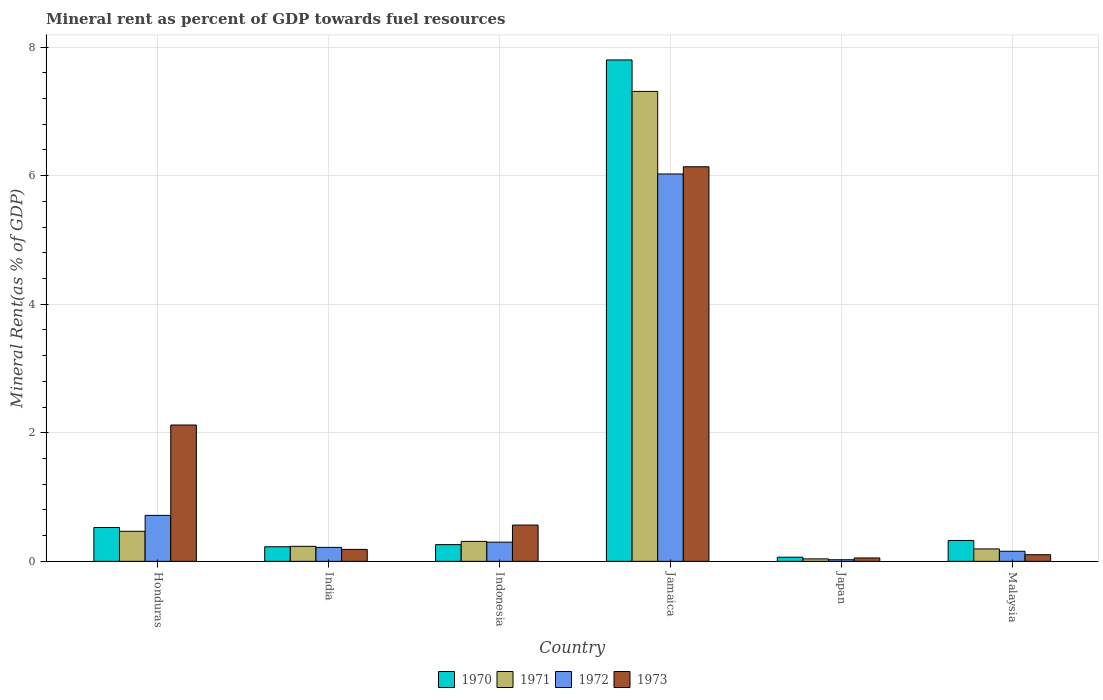How many different coloured bars are there?
Your answer should be compact. 4. How many groups of bars are there?
Your answer should be very brief. 6. Are the number of bars on each tick of the X-axis equal?
Provide a succinct answer. Yes. How many bars are there on the 1st tick from the left?
Give a very brief answer. 4. What is the label of the 6th group of bars from the left?
Give a very brief answer. Malaysia. What is the mineral rent in 1971 in Jamaica?
Your response must be concise. 7.31. Across all countries, what is the maximum mineral rent in 1971?
Keep it short and to the point. 7.31. Across all countries, what is the minimum mineral rent in 1971?
Give a very brief answer. 0.04. In which country was the mineral rent in 1971 maximum?
Your answer should be compact. Jamaica. In which country was the mineral rent in 1971 minimum?
Offer a very short reply. Japan. What is the total mineral rent in 1970 in the graph?
Ensure brevity in your answer.  9.2. What is the difference between the mineral rent in 1973 in Honduras and that in Indonesia?
Ensure brevity in your answer.  1.56. What is the difference between the mineral rent in 1971 in Japan and the mineral rent in 1973 in Honduras?
Offer a very short reply. -2.08. What is the average mineral rent in 1970 per country?
Your response must be concise. 1.53. What is the difference between the mineral rent of/in 1972 and mineral rent of/in 1970 in Indonesia?
Your answer should be compact. 0.04. In how many countries, is the mineral rent in 1973 greater than 2.4 %?
Make the answer very short. 1. What is the ratio of the mineral rent in 1973 in Honduras to that in Jamaica?
Keep it short and to the point. 0.35. Is the mineral rent in 1971 in India less than that in Japan?
Make the answer very short. No. Is the difference between the mineral rent in 1972 in Jamaica and Malaysia greater than the difference between the mineral rent in 1970 in Jamaica and Malaysia?
Your answer should be very brief. No. What is the difference between the highest and the second highest mineral rent in 1972?
Provide a succinct answer. 0.42. What is the difference between the highest and the lowest mineral rent in 1972?
Keep it short and to the point. 6. In how many countries, is the mineral rent in 1973 greater than the average mineral rent in 1973 taken over all countries?
Offer a very short reply. 2. Is it the case that in every country, the sum of the mineral rent in 1973 and mineral rent in 1970 is greater than the sum of mineral rent in 1971 and mineral rent in 1972?
Offer a terse response. No. Are all the bars in the graph horizontal?
Your response must be concise. No. How many countries are there in the graph?
Keep it short and to the point. 6. What is the difference between two consecutive major ticks on the Y-axis?
Your answer should be very brief. 2. Does the graph contain any zero values?
Offer a terse response. No. How many legend labels are there?
Make the answer very short. 4. What is the title of the graph?
Your response must be concise. Mineral rent as percent of GDP towards fuel resources. Does "1974" appear as one of the legend labels in the graph?
Make the answer very short. No. What is the label or title of the X-axis?
Ensure brevity in your answer.  Country. What is the label or title of the Y-axis?
Provide a short and direct response. Mineral Rent(as % of GDP). What is the Mineral Rent(as % of GDP) of 1970 in Honduras?
Offer a very short reply. 0.53. What is the Mineral Rent(as % of GDP) of 1971 in Honduras?
Offer a very short reply. 0.47. What is the Mineral Rent(as % of GDP) in 1972 in Honduras?
Keep it short and to the point. 0.72. What is the Mineral Rent(as % of GDP) of 1973 in Honduras?
Offer a very short reply. 2.12. What is the Mineral Rent(as % of GDP) in 1970 in India?
Ensure brevity in your answer.  0.23. What is the Mineral Rent(as % of GDP) in 1971 in India?
Your response must be concise. 0.23. What is the Mineral Rent(as % of GDP) in 1972 in India?
Provide a succinct answer. 0.22. What is the Mineral Rent(as % of GDP) of 1973 in India?
Your answer should be compact. 0.19. What is the Mineral Rent(as % of GDP) of 1970 in Indonesia?
Offer a terse response. 0.26. What is the Mineral Rent(as % of GDP) of 1971 in Indonesia?
Offer a very short reply. 0.31. What is the Mineral Rent(as % of GDP) of 1972 in Indonesia?
Give a very brief answer. 0.3. What is the Mineral Rent(as % of GDP) of 1973 in Indonesia?
Provide a short and direct response. 0.56. What is the Mineral Rent(as % of GDP) in 1970 in Jamaica?
Ensure brevity in your answer.  7.8. What is the Mineral Rent(as % of GDP) of 1971 in Jamaica?
Your answer should be compact. 7.31. What is the Mineral Rent(as % of GDP) of 1972 in Jamaica?
Provide a short and direct response. 6.03. What is the Mineral Rent(as % of GDP) in 1973 in Jamaica?
Offer a very short reply. 6.14. What is the Mineral Rent(as % of GDP) of 1970 in Japan?
Your answer should be compact. 0.06. What is the Mineral Rent(as % of GDP) in 1971 in Japan?
Give a very brief answer. 0.04. What is the Mineral Rent(as % of GDP) of 1972 in Japan?
Give a very brief answer. 0.03. What is the Mineral Rent(as % of GDP) of 1973 in Japan?
Keep it short and to the point. 0.05. What is the Mineral Rent(as % of GDP) in 1970 in Malaysia?
Your response must be concise. 0.33. What is the Mineral Rent(as % of GDP) in 1971 in Malaysia?
Provide a short and direct response. 0.19. What is the Mineral Rent(as % of GDP) of 1972 in Malaysia?
Make the answer very short. 0.16. What is the Mineral Rent(as % of GDP) of 1973 in Malaysia?
Give a very brief answer. 0.1. Across all countries, what is the maximum Mineral Rent(as % of GDP) of 1970?
Offer a terse response. 7.8. Across all countries, what is the maximum Mineral Rent(as % of GDP) in 1971?
Provide a succinct answer. 7.31. Across all countries, what is the maximum Mineral Rent(as % of GDP) of 1972?
Give a very brief answer. 6.03. Across all countries, what is the maximum Mineral Rent(as % of GDP) of 1973?
Provide a succinct answer. 6.14. Across all countries, what is the minimum Mineral Rent(as % of GDP) in 1970?
Provide a short and direct response. 0.06. Across all countries, what is the minimum Mineral Rent(as % of GDP) in 1971?
Your answer should be very brief. 0.04. Across all countries, what is the minimum Mineral Rent(as % of GDP) in 1972?
Provide a succinct answer. 0.03. Across all countries, what is the minimum Mineral Rent(as % of GDP) in 1973?
Your response must be concise. 0.05. What is the total Mineral Rent(as % of GDP) of 1970 in the graph?
Your response must be concise. 9.2. What is the total Mineral Rent(as % of GDP) of 1971 in the graph?
Make the answer very short. 8.55. What is the total Mineral Rent(as % of GDP) in 1972 in the graph?
Offer a very short reply. 7.44. What is the total Mineral Rent(as % of GDP) in 1973 in the graph?
Offer a very short reply. 9.17. What is the difference between the Mineral Rent(as % of GDP) of 1970 in Honduras and that in India?
Make the answer very short. 0.3. What is the difference between the Mineral Rent(as % of GDP) in 1971 in Honduras and that in India?
Keep it short and to the point. 0.23. What is the difference between the Mineral Rent(as % of GDP) of 1972 in Honduras and that in India?
Ensure brevity in your answer.  0.5. What is the difference between the Mineral Rent(as % of GDP) of 1973 in Honduras and that in India?
Ensure brevity in your answer.  1.94. What is the difference between the Mineral Rent(as % of GDP) of 1970 in Honduras and that in Indonesia?
Your answer should be compact. 0.27. What is the difference between the Mineral Rent(as % of GDP) of 1971 in Honduras and that in Indonesia?
Your response must be concise. 0.16. What is the difference between the Mineral Rent(as % of GDP) of 1972 in Honduras and that in Indonesia?
Provide a succinct answer. 0.42. What is the difference between the Mineral Rent(as % of GDP) in 1973 in Honduras and that in Indonesia?
Offer a terse response. 1.56. What is the difference between the Mineral Rent(as % of GDP) in 1970 in Honduras and that in Jamaica?
Ensure brevity in your answer.  -7.27. What is the difference between the Mineral Rent(as % of GDP) of 1971 in Honduras and that in Jamaica?
Keep it short and to the point. -6.84. What is the difference between the Mineral Rent(as % of GDP) of 1972 in Honduras and that in Jamaica?
Your answer should be compact. -5.31. What is the difference between the Mineral Rent(as % of GDP) in 1973 in Honduras and that in Jamaica?
Ensure brevity in your answer.  -4.02. What is the difference between the Mineral Rent(as % of GDP) in 1970 in Honduras and that in Japan?
Offer a terse response. 0.46. What is the difference between the Mineral Rent(as % of GDP) in 1971 in Honduras and that in Japan?
Offer a very short reply. 0.43. What is the difference between the Mineral Rent(as % of GDP) of 1972 in Honduras and that in Japan?
Offer a terse response. 0.69. What is the difference between the Mineral Rent(as % of GDP) of 1973 in Honduras and that in Japan?
Give a very brief answer. 2.07. What is the difference between the Mineral Rent(as % of GDP) of 1970 in Honduras and that in Malaysia?
Offer a very short reply. 0.2. What is the difference between the Mineral Rent(as % of GDP) in 1971 in Honduras and that in Malaysia?
Give a very brief answer. 0.27. What is the difference between the Mineral Rent(as % of GDP) in 1972 in Honduras and that in Malaysia?
Give a very brief answer. 0.56. What is the difference between the Mineral Rent(as % of GDP) of 1973 in Honduras and that in Malaysia?
Make the answer very short. 2.02. What is the difference between the Mineral Rent(as % of GDP) of 1970 in India and that in Indonesia?
Your response must be concise. -0.03. What is the difference between the Mineral Rent(as % of GDP) of 1971 in India and that in Indonesia?
Offer a very short reply. -0.08. What is the difference between the Mineral Rent(as % of GDP) in 1972 in India and that in Indonesia?
Your answer should be very brief. -0.08. What is the difference between the Mineral Rent(as % of GDP) in 1973 in India and that in Indonesia?
Offer a terse response. -0.38. What is the difference between the Mineral Rent(as % of GDP) in 1970 in India and that in Jamaica?
Offer a very short reply. -7.57. What is the difference between the Mineral Rent(as % of GDP) in 1971 in India and that in Jamaica?
Offer a terse response. -7.08. What is the difference between the Mineral Rent(as % of GDP) in 1972 in India and that in Jamaica?
Your answer should be very brief. -5.81. What is the difference between the Mineral Rent(as % of GDP) of 1973 in India and that in Jamaica?
Provide a succinct answer. -5.95. What is the difference between the Mineral Rent(as % of GDP) of 1970 in India and that in Japan?
Ensure brevity in your answer.  0.16. What is the difference between the Mineral Rent(as % of GDP) of 1971 in India and that in Japan?
Make the answer very short. 0.2. What is the difference between the Mineral Rent(as % of GDP) in 1972 in India and that in Japan?
Make the answer very short. 0.19. What is the difference between the Mineral Rent(as % of GDP) of 1973 in India and that in Japan?
Ensure brevity in your answer.  0.13. What is the difference between the Mineral Rent(as % of GDP) of 1970 in India and that in Malaysia?
Your answer should be very brief. -0.1. What is the difference between the Mineral Rent(as % of GDP) of 1971 in India and that in Malaysia?
Ensure brevity in your answer.  0.04. What is the difference between the Mineral Rent(as % of GDP) in 1972 in India and that in Malaysia?
Keep it short and to the point. 0.06. What is the difference between the Mineral Rent(as % of GDP) of 1973 in India and that in Malaysia?
Offer a terse response. 0.08. What is the difference between the Mineral Rent(as % of GDP) in 1970 in Indonesia and that in Jamaica?
Provide a succinct answer. -7.54. What is the difference between the Mineral Rent(as % of GDP) in 1971 in Indonesia and that in Jamaica?
Give a very brief answer. -7. What is the difference between the Mineral Rent(as % of GDP) in 1972 in Indonesia and that in Jamaica?
Your response must be concise. -5.73. What is the difference between the Mineral Rent(as % of GDP) of 1973 in Indonesia and that in Jamaica?
Your answer should be very brief. -5.57. What is the difference between the Mineral Rent(as % of GDP) in 1970 in Indonesia and that in Japan?
Provide a succinct answer. 0.2. What is the difference between the Mineral Rent(as % of GDP) of 1971 in Indonesia and that in Japan?
Offer a terse response. 0.27. What is the difference between the Mineral Rent(as % of GDP) of 1972 in Indonesia and that in Japan?
Ensure brevity in your answer.  0.27. What is the difference between the Mineral Rent(as % of GDP) of 1973 in Indonesia and that in Japan?
Keep it short and to the point. 0.51. What is the difference between the Mineral Rent(as % of GDP) of 1970 in Indonesia and that in Malaysia?
Your answer should be very brief. -0.07. What is the difference between the Mineral Rent(as % of GDP) of 1971 in Indonesia and that in Malaysia?
Offer a terse response. 0.12. What is the difference between the Mineral Rent(as % of GDP) in 1972 in Indonesia and that in Malaysia?
Provide a short and direct response. 0.14. What is the difference between the Mineral Rent(as % of GDP) in 1973 in Indonesia and that in Malaysia?
Keep it short and to the point. 0.46. What is the difference between the Mineral Rent(as % of GDP) of 1970 in Jamaica and that in Japan?
Keep it short and to the point. 7.73. What is the difference between the Mineral Rent(as % of GDP) in 1971 in Jamaica and that in Japan?
Ensure brevity in your answer.  7.27. What is the difference between the Mineral Rent(as % of GDP) of 1972 in Jamaica and that in Japan?
Your answer should be compact. 6. What is the difference between the Mineral Rent(as % of GDP) in 1973 in Jamaica and that in Japan?
Make the answer very short. 6.08. What is the difference between the Mineral Rent(as % of GDP) in 1970 in Jamaica and that in Malaysia?
Your answer should be very brief. 7.47. What is the difference between the Mineral Rent(as % of GDP) of 1971 in Jamaica and that in Malaysia?
Provide a short and direct response. 7.12. What is the difference between the Mineral Rent(as % of GDP) of 1972 in Jamaica and that in Malaysia?
Your answer should be compact. 5.87. What is the difference between the Mineral Rent(as % of GDP) of 1973 in Jamaica and that in Malaysia?
Your response must be concise. 6.03. What is the difference between the Mineral Rent(as % of GDP) of 1970 in Japan and that in Malaysia?
Offer a very short reply. -0.26. What is the difference between the Mineral Rent(as % of GDP) of 1971 in Japan and that in Malaysia?
Offer a very short reply. -0.16. What is the difference between the Mineral Rent(as % of GDP) of 1972 in Japan and that in Malaysia?
Provide a succinct answer. -0.13. What is the difference between the Mineral Rent(as % of GDP) in 1973 in Japan and that in Malaysia?
Your response must be concise. -0.05. What is the difference between the Mineral Rent(as % of GDP) of 1970 in Honduras and the Mineral Rent(as % of GDP) of 1971 in India?
Keep it short and to the point. 0.29. What is the difference between the Mineral Rent(as % of GDP) in 1970 in Honduras and the Mineral Rent(as % of GDP) in 1972 in India?
Give a very brief answer. 0.31. What is the difference between the Mineral Rent(as % of GDP) in 1970 in Honduras and the Mineral Rent(as % of GDP) in 1973 in India?
Provide a succinct answer. 0.34. What is the difference between the Mineral Rent(as % of GDP) in 1971 in Honduras and the Mineral Rent(as % of GDP) in 1972 in India?
Provide a succinct answer. 0.25. What is the difference between the Mineral Rent(as % of GDP) of 1971 in Honduras and the Mineral Rent(as % of GDP) of 1973 in India?
Provide a succinct answer. 0.28. What is the difference between the Mineral Rent(as % of GDP) of 1972 in Honduras and the Mineral Rent(as % of GDP) of 1973 in India?
Ensure brevity in your answer.  0.53. What is the difference between the Mineral Rent(as % of GDP) of 1970 in Honduras and the Mineral Rent(as % of GDP) of 1971 in Indonesia?
Provide a short and direct response. 0.22. What is the difference between the Mineral Rent(as % of GDP) of 1970 in Honduras and the Mineral Rent(as % of GDP) of 1972 in Indonesia?
Your response must be concise. 0.23. What is the difference between the Mineral Rent(as % of GDP) in 1970 in Honduras and the Mineral Rent(as % of GDP) in 1973 in Indonesia?
Give a very brief answer. -0.04. What is the difference between the Mineral Rent(as % of GDP) of 1971 in Honduras and the Mineral Rent(as % of GDP) of 1972 in Indonesia?
Provide a short and direct response. 0.17. What is the difference between the Mineral Rent(as % of GDP) of 1971 in Honduras and the Mineral Rent(as % of GDP) of 1973 in Indonesia?
Your answer should be compact. -0.1. What is the difference between the Mineral Rent(as % of GDP) of 1972 in Honduras and the Mineral Rent(as % of GDP) of 1973 in Indonesia?
Keep it short and to the point. 0.15. What is the difference between the Mineral Rent(as % of GDP) in 1970 in Honduras and the Mineral Rent(as % of GDP) in 1971 in Jamaica?
Provide a succinct answer. -6.78. What is the difference between the Mineral Rent(as % of GDP) of 1970 in Honduras and the Mineral Rent(as % of GDP) of 1972 in Jamaica?
Give a very brief answer. -5.5. What is the difference between the Mineral Rent(as % of GDP) in 1970 in Honduras and the Mineral Rent(as % of GDP) in 1973 in Jamaica?
Provide a short and direct response. -5.61. What is the difference between the Mineral Rent(as % of GDP) of 1971 in Honduras and the Mineral Rent(as % of GDP) of 1972 in Jamaica?
Make the answer very short. -5.56. What is the difference between the Mineral Rent(as % of GDP) of 1971 in Honduras and the Mineral Rent(as % of GDP) of 1973 in Jamaica?
Offer a terse response. -5.67. What is the difference between the Mineral Rent(as % of GDP) of 1972 in Honduras and the Mineral Rent(as % of GDP) of 1973 in Jamaica?
Your answer should be very brief. -5.42. What is the difference between the Mineral Rent(as % of GDP) of 1970 in Honduras and the Mineral Rent(as % of GDP) of 1971 in Japan?
Your answer should be compact. 0.49. What is the difference between the Mineral Rent(as % of GDP) in 1970 in Honduras and the Mineral Rent(as % of GDP) in 1972 in Japan?
Give a very brief answer. 0.5. What is the difference between the Mineral Rent(as % of GDP) of 1970 in Honduras and the Mineral Rent(as % of GDP) of 1973 in Japan?
Your answer should be compact. 0.47. What is the difference between the Mineral Rent(as % of GDP) of 1971 in Honduras and the Mineral Rent(as % of GDP) of 1972 in Japan?
Offer a very short reply. 0.44. What is the difference between the Mineral Rent(as % of GDP) of 1971 in Honduras and the Mineral Rent(as % of GDP) of 1973 in Japan?
Your response must be concise. 0.41. What is the difference between the Mineral Rent(as % of GDP) of 1972 in Honduras and the Mineral Rent(as % of GDP) of 1973 in Japan?
Offer a very short reply. 0.66. What is the difference between the Mineral Rent(as % of GDP) in 1970 in Honduras and the Mineral Rent(as % of GDP) in 1971 in Malaysia?
Offer a terse response. 0.33. What is the difference between the Mineral Rent(as % of GDP) of 1970 in Honduras and the Mineral Rent(as % of GDP) of 1972 in Malaysia?
Offer a very short reply. 0.37. What is the difference between the Mineral Rent(as % of GDP) of 1970 in Honduras and the Mineral Rent(as % of GDP) of 1973 in Malaysia?
Give a very brief answer. 0.42. What is the difference between the Mineral Rent(as % of GDP) of 1971 in Honduras and the Mineral Rent(as % of GDP) of 1972 in Malaysia?
Offer a very short reply. 0.31. What is the difference between the Mineral Rent(as % of GDP) in 1971 in Honduras and the Mineral Rent(as % of GDP) in 1973 in Malaysia?
Your response must be concise. 0.36. What is the difference between the Mineral Rent(as % of GDP) in 1972 in Honduras and the Mineral Rent(as % of GDP) in 1973 in Malaysia?
Offer a very short reply. 0.61. What is the difference between the Mineral Rent(as % of GDP) of 1970 in India and the Mineral Rent(as % of GDP) of 1971 in Indonesia?
Ensure brevity in your answer.  -0.08. What is the difference between the Mineral Rent(as % of GDP) in 1970 in India and the Mineral Rent(as % of GDP) in 1972 in Indonesia?
Your answer should be compact. -0.07. What is the difference between the Mineral Rent(as % of GDP) of 1970 in India and the Mineral Rent(as % of GDP) of 1973 in Indonesia?
Your response must be concise. -0.34. What is the difference between the Mineral Rent(as % of GDP) of 1971 in India and the Mineral Rent(as % of GDP) of 1972 in Indonesia?
Keep it short and to the point. -0.07. What is the difference between the Mineral Rent(as % of GDP) of 1971 in India and the Mineral Rent(as % of GDP) of 1973 in Indonesia?
Provide a succinct answer. -0.33. What is the difference between the Mineral Rent(as % of GDP) of 1972 in India and the Mineral Rent(as % of GDP) of 1973 in Indonesia?
Give a very brief answer. -0.35. What is the difference between the Mineral Rent(as % of GDP) in 1970 in India and the Mineral Rent(as % of GDP) in 1971 in Jamaica?
Provide a succinct answer. -7.08. What is the difference between the Mineral Rent(as % of GDP) of 1970 in India and the Mineral Rent(as % of GDP) of 1972 in Jamaica?
Make the answer very short. -5.8. What is the difference between the Mineral Rent(as % of GDP) in 1970 in India and the Mineral Rent(as % of GDP) in 1973 in Jamaica?
Provide a succinct answer. -5.91. What is the difference between the Mineral Rent(as % of GDP) in 1971 in India and the Mineral Rent(as % of GDP) in 1972 in Jamaica?
Keep it short and to the point. -5.79. What is the difference between the Mineral Rent(as % of GDP) of 1971 in India and the Mineral Rent(as % of GDP) of 1973 in Jamaica?
Your answer should be very brief. -5.9. What is the difference between the Mineral Rent(as % of GDP) in 1972 in India and the Mineral Rent(as % of GDP) in 1973 in Jamaica?
Provide a short and direct response. -5.92. What is the difference between the Mineral Rent(as % of GDP) of 1970 in India and the Mineral Rent(as % of GDP) of 1971 in Japan?
Your answer should be very brief. 0.19. What is the difference between the Mineral Rent(as % of GDP) in 1970 in India and the Mineral Rent(as % of GDP) in 1972 in Japan?
Give a very brief answer. 0.2. What is the difference between the Mineral Rent(as % of GDP) of 1970 in India and the Mineral Rent(as % of GDP) of 1973 in Japan?
Keep it short and to the point. 0.17. What is the difference between the Mineral Rent(as % of GDP) of 1971 in India and the Mineral Rent(as % of GDP) of 1972 in Japan?
Make the answer very short. 0.21. What is the difference between the Mineral Rent(as % of GDP) of 1971 in India and the Mineral Rent(as % of GDP) of 1973 in Japan?
Your response must be concise. 0.18. What is the difference between the Mineral Rent(as % of GDP) of 1972 in India and the Mineral Rent(as % of GDP) of 1973 in Japan?
Offer a very short reply. 0.16. What is the difference between the Mineral Rent(as % of GDP) in 1970 in India and the Mineral Rent(as % of GDP) in 1972 in Malaysia?
Offer a terse response. 0.07. What is the difference between the Mineral Rent(as % of GDP) in 1970 in India and the Mineral Rent(as % of GDP) in 1973 in Malaysia?
Keep it short and to the point. 0.12. What is the difference between the Mineral Rent(as % of GDP) of 1971 in India and the Mineral Rent(as % of GDP) of 1972 in Malaysia?
Your answer should be compact. 0.08. What is the difference between the Mineral Rent(as % of GDP) in 1971 in India and the Mineral Rent(as % of GDP) in 1973 in Malaysia?
Give a very brief answer. 0.13. What is the difference between the Mineral Rent(as % of GDP) in 1972 in India and the Mineral Rent(as % of GDP) in 1973 in Malaysia?
Provide a short and direct response. 0.11. What is the difference between the Mineral Rent(as % of GDP) in 1970 in Indonesia and the Mineral Rent(as % of GDP) in 1971 in Jamaica?
Make the answer very short. -7.05. What is the difference between the Mineral Rent(as % of GDP) of 1970 in Indonesia and the Mineral Rent(as % of GDP) of 1972 in Jamaica?
Your answer should be compact. -5.77. What is the difference between the Mineral Rent(as % of GDP) of 1970 in Indonesia and the Mineral Rent(as % of GDP) of 1973 in Jamaica?
Your response must be concise. -5.88. What is the difference between the Mineral Rent(as % of GDP) in 1971 in Indonesia and the Mineral Rent(as % of GDP) in 1972 in Jamaica?
Ensure brevity in your answer.  -5.72. What is the difference between the Mineral Rent(as % of GDP) of 1971 in Indonesia and the Mineral Rent(as % of GDP) of 1973 in Jamaica?
Give a very brief answer. -5.83. What is the difference between the Mineral Rent(as % of GDP) of 1972 in Indonesia and the Mineral Rent(as % of GDP) of 1973 in Jamaica?
Your response must be concise. -5.84. What is the difference between the Mineral Rent(as % of GDP) in 1970 in Indonesia and the Mineral Rent(as % of GDP) in 1971 in Japan?
Your answer should be compact. 0.22. What is the difference between the Mineral Rent(as % of GDP) in 1970 in Indonesia and the Mineral Rent(as % of GDP) in 1972 in Japan?
Keep it short and to the point. 0.23. What is the difference between the Mineral Rent(as % of GDP) in 1970 in Indonesia and the Mineral Rent(as % of GDP) in 1973 in Japan?
Offer a very short reply. 0.21. What is the difference between the Mineral Rent(as % of GDP) in 1971 in Indonesia and the Mineral Rent(as % of GDP) in 1972 in Japan?
Keep it short and to the point. 0.29. What is the difference between the Mineral Rent(as % of GDP) of 1971 in Indonesia and the Mineral Rent(as % of GDP) of 1973 in Japan?
Provide a short and direct response. 0.26. What is the difference between the Mineral Rent(as % of GDP) of 1972 in Indonesia and the Mineral Rent(as % of GDP) of 1973 in Japan?
Provide a succinct answer. 0.25. What is the difference between the Mineral Rent(as % of GDP) of 1970 in Indonesia and the Mineral Rent(as % of GDP) of 1971 in Malaysia?
Provide a succinct answer. 0.07. What is the difference between the Mineral Rent(as % of GDP) in 1970 in Indonesia and the Mineral Rent(as % of GDP) in 1972 in Malaysia?
Your answer should be compact. 0.1. What is the difference between the Mineral Rent(as % of GDP) of 1970 in Indonesia and the Mineral Rent(as % of GDP) of 1973 in Malaysia?
Offer a terse response. 0.16. What is the difference between the Mineral Rent(as % of GDP) of 1971 in Indonesia and the Mineral Rent(as % of GDP) of 1972 in Malaysia?
Provide a short and direct response. 0.15. What is the difference between the Mineral Rent(as % of GDP) of 1971 in Indonesia and the Mineral Rent(as % of GDP) of 1973 in Malaysia?
Offer a terse response. 0.21. What is the difference between the Mineral Rent(as % of GDP) of 1972 in Indonesia and the Mineral Rent(as % of GDP) of 1973 in Malaysia?
Your answer should be compact. 0.2. What is the difference between the Mineral Rent(as % of GDP) of 1970 in Jamaica and the Mineral Rent(as % of GDP) of 1971 in Japan?
Provide a short and direct response. 7.76. What is the difference between the Mineral Rent(as % of GDP) of 1970 in Jamaica and the Mineral Rent(as % of GDP) of 1972 in Japan?
Offer a very short reply. 7.77. What is the difference between the Mineral Rent(as % of GDP) in 1970 in Jamaica and the Mineral Rent(as % of GDP) in 1973 in Japan?
Your response must be concise. 7.75. What is the difference between the Mineral Rent(as % of GDP) of 1971 in Jamaica and the Mineral Rent(as % of GDP) of 1972 in Japan?
Your answer should be compact. 7.28. What is the difference between the Mineral Rent(as % of GDP) of 1971 in Jamaica and the Mineral Rent(as % of GDP) of 1973 in Japan?
Provide a succinct answer. 7.26. What is the difference between the Mineral Rent(as % of GDP) of 1972 in Jamaica and the Mineral Rent(as % of GDP) of 1973 in Japan?
Your answer should be very brief. 5.97. What is the difference between the Mineral Rent(as % of GDP) in 1970 in Jamaica and the Mineral Rent(as % of GDP) in 1971 in Malaysia?
Provide a short and direct response. 7.61. What is the difference between the Mineral Rent(as % of GDP) in 1970 in Jamaica and the Mineral Rent(as % of GDP) in 1972 in Malaysia?
Offer a very short reply. 7.64. What is the difference between the Mineral Rent(as % of GDP) in 1970 in Jamaica and the Mineral Rent(as % of GDP) in 1973 in Malaysia?
Offer a terse response. 7.7. What is the difference between the Mineral Rent(as % of GDP) of 1971 in Jamaica and the Mineral Rent(as % of GDP) of 1972 in Malaysia?
Your response must be concise. 7.15. What is the difference between the Mineral Rent(as % of GDP) in 1971 in Jamaica and the Mineral Rent(as % of GDP) in 1973 in Malaysia?
Provide a short and direct response. 7.21. What is the difference between the Mineral Rent(as % of GDP) of 1972 in Jamaica and the Mineral Rent(as % of GDP) of 1973 in Malaysia?
Offer a very short reply. 5.92. What is the difference between the Mineral Rent(as % of GDP) of 1970 in Japan and the Mineral Rent(as % of GDP) of 1971 in Malaysia?
Provide a short and direct response. -0.13. What is the difference between the Mineral Rent(as % of GDP) of 1970 in Japan and the Mineral Rent(as % of GDP) of 1972 in Malaysia?
Provide a succinct answer. -0.09. What is the difference between the Mineral Rent(as % of GDP) in 1970 in Japan and the Mineral Rent(as % of GDP) in 1973 in Malaysia?
Offer a very short reply. -0.04. What is the difference between the Mineral Rent(as % of GDP) of 1971 in Japan and the Mineral Rent(as % of GDP) of 1972 in Malaysia?
Keep it short and to the point. -0.12. What is the difference between the Mineral Rent(as % of GDP) of 1971 in Japan and the Mineral Rent(as % of GDP) of 1973 in Malaysia?
Offer a very short reply. -0.06. What is the difference between the Mineral Rent(as % of GDP) of 1972 in Japan and the Mineral Rent(as % of GDP) of 1973 in Malaysia?
Keep it short and to the point. -0.08. What is the average Mineral Rent(as % of GDP) of 1970 per country?
Offer a terse response. 1.53. What is the average Mineral Rent(as % of GDP) of 1971 per country?
Give a very brief answer. 1.43. What is the average Mineral Rent(as % of GDP) in 1972 per country?
Your answer should be very brief. 1.24. What is the average Mineral Rent(as % of GDP) of 1973 per country?
Provide a short and direct response. 1.53. What is the difference between the Mineral Rent(as % of GDP) of 1970 and Mineral Rent(as % of GDP) of 1971 in Honduras?
Provide a succinct answer. 0.06. What is the difference between the Mineral Rent(as % of GDP) of 1970 and Mineral Rent(as % of GDP) of 1972 in Honduras?
Your answer should be compact. -0.19. What is the difference between the Mineral Rent(as % of GDP) in 1970 and Mineral Rent(as % of GDP) in 1973 in Honduras?
Your answer should be compact. -1.59. What is the difference between the Mineral Rent(as % of GDP) in 1971 and Mineral Rent(as % of GDP) in 1972 in Honduras?
Keep it short and to the point. -0.25. What is the difference between the Mineral Rent(as % of GDP) of 1971 and Mineral Rent(as % of GDP) of 1973 in Honduras?
Provide a short and direct response. -1.65. What is the difference between the Mineral Rent(as % of GDP) in 1972 and Mineral Rent(as % of GDP) in 1973 in Honduras?
Your answer should be compact. -1.41. What is the difference between the Mineral Rent(as % of GDP) of 1970 and Mineral Rent(as % of GDP) of 1971 in India?
Give a very brief answer. -0.01. What is the difference between the Mineral Rent(as % of GDP) of 1970 and Mineral Rent(as % of GDP) of 1972 in India?
Provide a short and direct response. 0.01. What is the difference between the Mineral Rent(as % of GDP) in 1970 and Mineral Rent(as % of GDP) in 1973 in India?
Your answer should be compact. 0.04. What is the difference between the Mineral Rent(as % of GDP) of 1971 and Mineral Rent(as % of GDP) of 1972 in India?
Give a very brief answer. 0.02. What is the difference between the Mineral Rent(as % of GDP) in 1971 and Mineral Rent(as % of GDP) in 1973 in India?
Provide a short and direct response. 0.05. What is the difference between the Mineral Rent(as % of GDP) of 1972 and Mineral Rent(as % of GDP) of 1973 in India?
Offer a very short reply. 0.03. What is the difference between the Mineral Rent(as % of GDP) of 1970 and Mineral Rent(as % of GDP) of 1971 in Indonesia?
Offer a very short reply. -0.05. What is the difference between the Mineral Rent(as % of GDP) of 1970 and Mineral Rent(as % of GDP) of 1972 in Indonesia?
Offer a terse response. -0.04. What is the difference between the Mineral Rent(as % of GDP) of 1970 and Mineral Rent(as % of GDP) of 1973 in Indonesia?
Your answer should be very brief. -0.3. What is the difference between the Mineral Rent(as % of GDP) in 1971 and Mineral Rent(as % of GDP) in 1972 in Indonesia?
Make the answer very short. 0.01. What is the difference between the Mineral Rent(as % of GDP) of 1971 and Mineral Rent(as % of GDP) of 1973 in Indonesia?
Give a very brief answer. -0.25. What is the difference between the Mineral Rent(as % of GDP) in 1972 and Mineral Rent(as % of GDP) in 1973 in Indonesia?
Offer a terse response. -0.27. What is the difference between the Mineral Rent(as % of GDP) of 1970 and Mineral Rent(as % of GDP) of 1971 in Jamaica?
Offer a terse response. 0.49. What is the difference between the Mineral Rent(as % of GDP) of 1970 and Mineral Rent(as % of GDP) of 1972 in Jamaica?
Offer a very short reply. 1.77. What is the difference between the Mineral Rent(as % of GDP) in 1970 and Mineral Rent(as % of GDP) in 1973 in Jamaica?
Offer a terse response. 1.66. What is the difference between the Mineral Rent(as % of GDP) of 1971 and Mineral Rent(as % of GDP) of 1972 in Jamaica?
Make the answer very short. 1.28. What is the difference between the Mineral Rent(as % of GDP) of 1971 and Mineral Rent(as % of GDP) of 1973 in Jamaica?
Make the answer very short. 1.17. What is the difference between the Mineral Rent(as % of GDP) of 1972 and Mineral Rent(as % of GDP) of 1973 in Jamaica?
Keep it short and to the point. -0.11. What is the difference between the Mineral Rent(as % of GDP) in 1970 and Mineral Rent(as % of GDP) in 1971 in Japan?
Keep it short and to the point. 0.03. What is the difference between the Mineral Rent(as % of GDP) of 1970 and Mineral Rent(as % of GDP) of 1972 in Japan?
Make the answer very short. 0.04. What is the difference between the Mineral Rent(as % of GDP) of 1970 and Mineral Rent(as % of GDP) of 1973 in Japan?
Your answer should be very brief. 0.01. What is the difference between the Mineral Rent(as % of GDP) in 1971 and Mineral Rent(as % of GDP) in 1972 in Japan?
Your answer should be compact. 0.01. What is the difference between the Mineral Rent(as % of GDP) of 1971 and Mineral Rent(as % of GDP) of 1973 in Japan?
Your answer should be very brief. -0.01. What is the difference between the Mineral Rent(as % of GDP) of 1972 and Mineral Rent(as % of GDP) of 1973 in Japan?
Your answer should be very brief. -0.03. What is the difference between the Mineral Rent(as % of GDP) in 1970 and Mineral Rent(as % of GDP) in 1971 in Malaysia?
Provide a short and direct response. 0.13. What is the difference between the Mineral Rent(as % of GDP) in 1970 and Mineral Rent(as % of GDP) in 1972 in Malaysia?
Keep it short and to the point. 0.17. What is the difference between the Mineral Rent(as % of GDP) of 1970 and Mineral Rent(as % of GDP) of 1973 in Malaysia?
Ensure brevity in your answer.  0.22. What is the difference between the Mineral Rent(as % of GDP) of 1971 and Mineral Rent(as % of GDP) of 1972 in Malaysia?
Your answer should be compact. 0.04. What is the difference between the Mineral Rent(as % of GDP) in 1971 and Mineral Rent(as % of GDP) in 1973 in Malaysia?
Make the answer very short. 0.09. What is the difference between the Mineral Rent(as % of GDP) in 1972 and Mineral Rent(as % of GDP) in 1973 in Malaysia?
Provide a short and direct response. 0.05. What is the ratio of the Mineral Rent(as % of GDP) in 1970 in Honduras to that in India?
Provide a succinct answer. 2.32. What is the ratio of the Mineral Rent(as % of GDP) of 1971 in Honduras to that in India?
Offer a terse response. 2. What is the ratio of the Mineral Rent(as % of GDP) of 1972 in Honduras to that in India?
Make the answer very short. 3.29. What is the ratio of the Mineral Rent(as % of GDP) of 1973 in Honduras to that in India?
Offer a very short reply. 11.41. What is the ratio of the Mineral Rent(as % of GDP) in 1970 in Honduras to that in Indonesia?
Offer a very short reply. 2.02. What is the ratio of the Mineral Rent(as % of GDP) in 1971 in Honduras to that in Indonesia?
Provide a short and direct response. 1.51. What is the ratio of the Mineral Rent(as % of GDP) of 1972 in Honduras to that in Indonesia?
Give a very brief answer. 2.4. What is the ratio of the Mineral Rent(as % of GDP) of 1973 in Honduras to that in Indonesia?
Ensure brevity in your answer.  3.76. What is the ratio of the Mineral Rent(as % of GDP) of 1970 in Honduras to that in Jamaica?
Provide a succinct answer. 0.07. What is the ratio of the Mineral Rent(as % of GDP) in 1971 in Honduras to that in Jamaica?
Your response must be concise. 0.06. What is the ratio of the Mineral Rent(as % of GDP) in 1972 in Honduras to that in Jamaica?
Keep it short and to the point. 0.12. What is the ratio of the Mineral Rent(as % of GDP) of 1973 in Honduras to that in Jamaica?
Ensure brevity in your answer.  0.35. What is the ratio of the Mineral Rent(as % of GDP) of 1970 in Honduras to that in Japan?
Make the answer very short. 8.11. What is the ratio of the Mineral Rent(as % of GDP) of 1971 in Honduras to that in Japan?
Your answer should be very brief. 12.13. What is the ratio of the Mineral Rent(as % of GDP) of 1972 in Honduras to that in Japan?
Provide a succinct answer. 28.32. What is the ratio of the Mineral Rent(as % of GDP) in 1973 in Honduras to that in Japan?
Keep it short and to the point. 40.15. What is the ratio of the Mineral Rent(as % of GDP) in 1970 in Honduras to that in Malaysia?
Offer a terse response. 1.62. What is the ratio of the Mineral Rent(as % of GDP) of 1971 in Honduras to that in Malaysia?
Your answer should be compact. 2.41. What is the ratio of the Mineral Rent(as % of GDP) of 1972 in Honduras to that in Malaysia?
Your answer should be compact. 4.56. What is the ratio of the Mineral Rent(as % of GDP) in 1973 in Honduras to that in Malaysia?
Make the answer very short. 20.56. What is the ratio of the Mineral Rent(as % of GDP) in 1970 in India to that in Indonesia?
Offer a very short reply. 0.87. What is the ratio of the Mineral Rent(as % of GDP) of 1971 in India to that in Indonesia?
Keep it short and to the point. 0.75. What is the ratio of the Mineral Rent(as % of GDP) in 1972 in India to that in Indonesia?
Your answer should be compact. 0.73. What is the ratio of the Mineral Rent(as % of GDP) of 1973 in India to that in Indonesia?
Give a very brief answer. 0.33. What is the ratio of the Mineral Rent(as % of GDP) of 1970 in India to that in Jamaica?
Your answer should be very brief. 0.03. What is the ratio of the Mineral Rent(as % of GDP) in 1971 in India to that in Jamaica?
Offer a very short reply. 0.03. What is the ratio of the Mineral Rent(as % of GDP) of 1972 in India to that in Jamaica?
Your answer should be very brief. 0.04. What is the ratio of the Mineral Rent(as % of GDP) of 1973 in India to that in Jamaica?
Offer a terse response. 0.03. What is the ratio of the Mineral Rent(as % of GDP) in 1970 in India to that in Japan?
Your answer should be compact. 3.5. What is the ratio of the Mineral Rent(as % of GDP) in 1971 in India to that in Japan?
Your response must be concise. 6.06. What is the ratio of the Mineral Rent(as % of GDP) of 1972 in India to that in Japan?
Provide a short and direct response. 8.6. What is the ratio of the Mineral Rent(as % of GDP) in 1973 in India to that in Japan?
Offer a very short reply. 3.52. What is the ratio of the Mineral Rent(as % of GDP) of 1970 in India to that in Malaysia?
Provide a short and direct response. 0.7. What is the ratio of the Mineral Rent(as % of GDP) in 1971 in India to that in Malaysia?
Ensure brevity in your answer.  1.21. What is the ratio of the Mineral Rent(as % of GDP) of 1972 in India to that in Malaysia?
Offer a terse response. 1.38. What is the ratio of the Mineral Rent(as % of GDP) in 1973 in India to that in Malaysia?
Provide a succinct answer. 1.8. What is the ratio of the Mineral Rent(as % of GDP) in 1971 in Indonesia to that in Jamaica?
Make the answer very short. 0.04. What is the ratio of the Mineral Rent(as % of GDP) of 1972 in Indonesia to that in Jamaica?
Offer a terse response. 0.05. What is the ratio of the Mineral Rent(as % of GDP) of 1973 in Indonesia to that in Jamaica?
Your answer should be very brief. 0.09. What is the ratio of the Mineral Rent(as % of GDP) in 1970 in Indonesia to that in Japan?
Make the answer very short. 4.01. What is the ratio of the Mineral Rent(as % of GDP) of 1971 in Indonesia to that in Japan?
Offer a very short reply. 8.06. What is the ratio of the Mineral Rent(as % of GDP) of 1972 in Indonesia to that in Japan?
Provide a short and direct response. 11.82. What is the ratio of the Mineral Rent(as % of GDP) in 1973 in Indonesia to that in Japan?
Your answer should be compact. 10.69. What is the ratio of the Mineral Rent(as % of GDP) of 1970 in Indonesia to that in Malaysia?
Your answer should be compact. 0.8. What is the ratio of the Mineral Rent(as % of GDP) of 1971 in Indonesia to that in Malaysia?
Give a very brief answer. 1.6. What is the ratio of the Mineral Rent(as % of GDP) in 1972 in Indonesia to that in Malaysia?
Offer a terse response. 1.9. What is the ratio of the Mineral Rent(as % of GDP) in 1973 in Indonesia to that in Malaysia?
Provide a succinct answer. 5.47. What is the ratio of the Mineral Rent(as % of GDP) of 1970 in Jamaica to that in Japan?
Offer a very short reply. 120.23. What is the ratio of the Mineral Rent(as % of GDP) of 1971 in Jamaica to that in Japan?
Your answer should be compact. 189.73. What is the ratio of the Mineral Rent(as % of GDP) in 1972 in Jamaica to that in Japan?
Offer a very short reply. 238.51. What is the ratio of the Mineral Rent(as % of GDP) in 1973 in Jamaica to that in Japan?
Your response must be concise. 116.18. What is the ratio of the Mineral Rent(as % of GDP) in 1970 in Jamaica to that in Malaysia?
Ensure brevity in your answer.  23.97. What is the ratio of the Mineral Rent(as % of GDP) of 1971 in Jamaica to that in Malaysia?
Your answer should be very brief. 37.76. What is the ratio of the Mineral Rent(as % of GDP) in 1972 in Jamaica to that in Malaysia?
Offer a very short reply. 38.36. What is the ratio of the Mineral Rent(as % of GDP) in 1973 in Jamaica to that in Malaysia?
Your answer should be compact. 59.49. What is the ratio of the Mineral Rent(as % of GDP) of 1970 in Japan to that in Malaysia?
Offer a terse response. 0.2. What is the ratio of the Mineral Rent(as % of GDP) of 1971 in Japan to that in Malaysia?
Make the answer very short. 0.2. What is the ratio of the Mineral Rent(as % of GDP) in 1972 in Japan to that in Malaysia?
Keep it short and to the point. 0.16. What is the ratio of the Mineral Rent(as % of GDP) of 1973 in Japan to that in Malaysia?
Keep it short and to the point. 0.51. What is the difference between the highest and the second highest Mineral Rent(as % of GDP) of 1970?
Provide a succinct answer. 7.27. What is the difference between the highest and the second highest Mineral Rent(as % of GDP) of 1971?
Ensure brevity in your answer.  6.84. What is the difference between the highest and the second highest Mineral Rent(as % of GDP) in 1972?
Keep it short and to the point. 5.31. What is the difference between the highest and the second highest Mineral Rent(as % of GDP) of 1973?
Offer a very short reply. 4.02. What is the difference between the highest and the lowest Mineral Rent(as % of GDP) of 1970?
Offer a very short reply. 7.73. What is the difference between the highest and the lowest Mineral Rent(as % of GDP) of 1971?
Offer a terse response. 7.27. What is the difference between the highest and the lowest Mineral Rent(as % of GDP) of 1972?
Give a very brief answer. 6. What is the difference between the highest and the lowest Mineral Rent(as % of GDP) in 1973?
Offer a terse response. 6.08. 